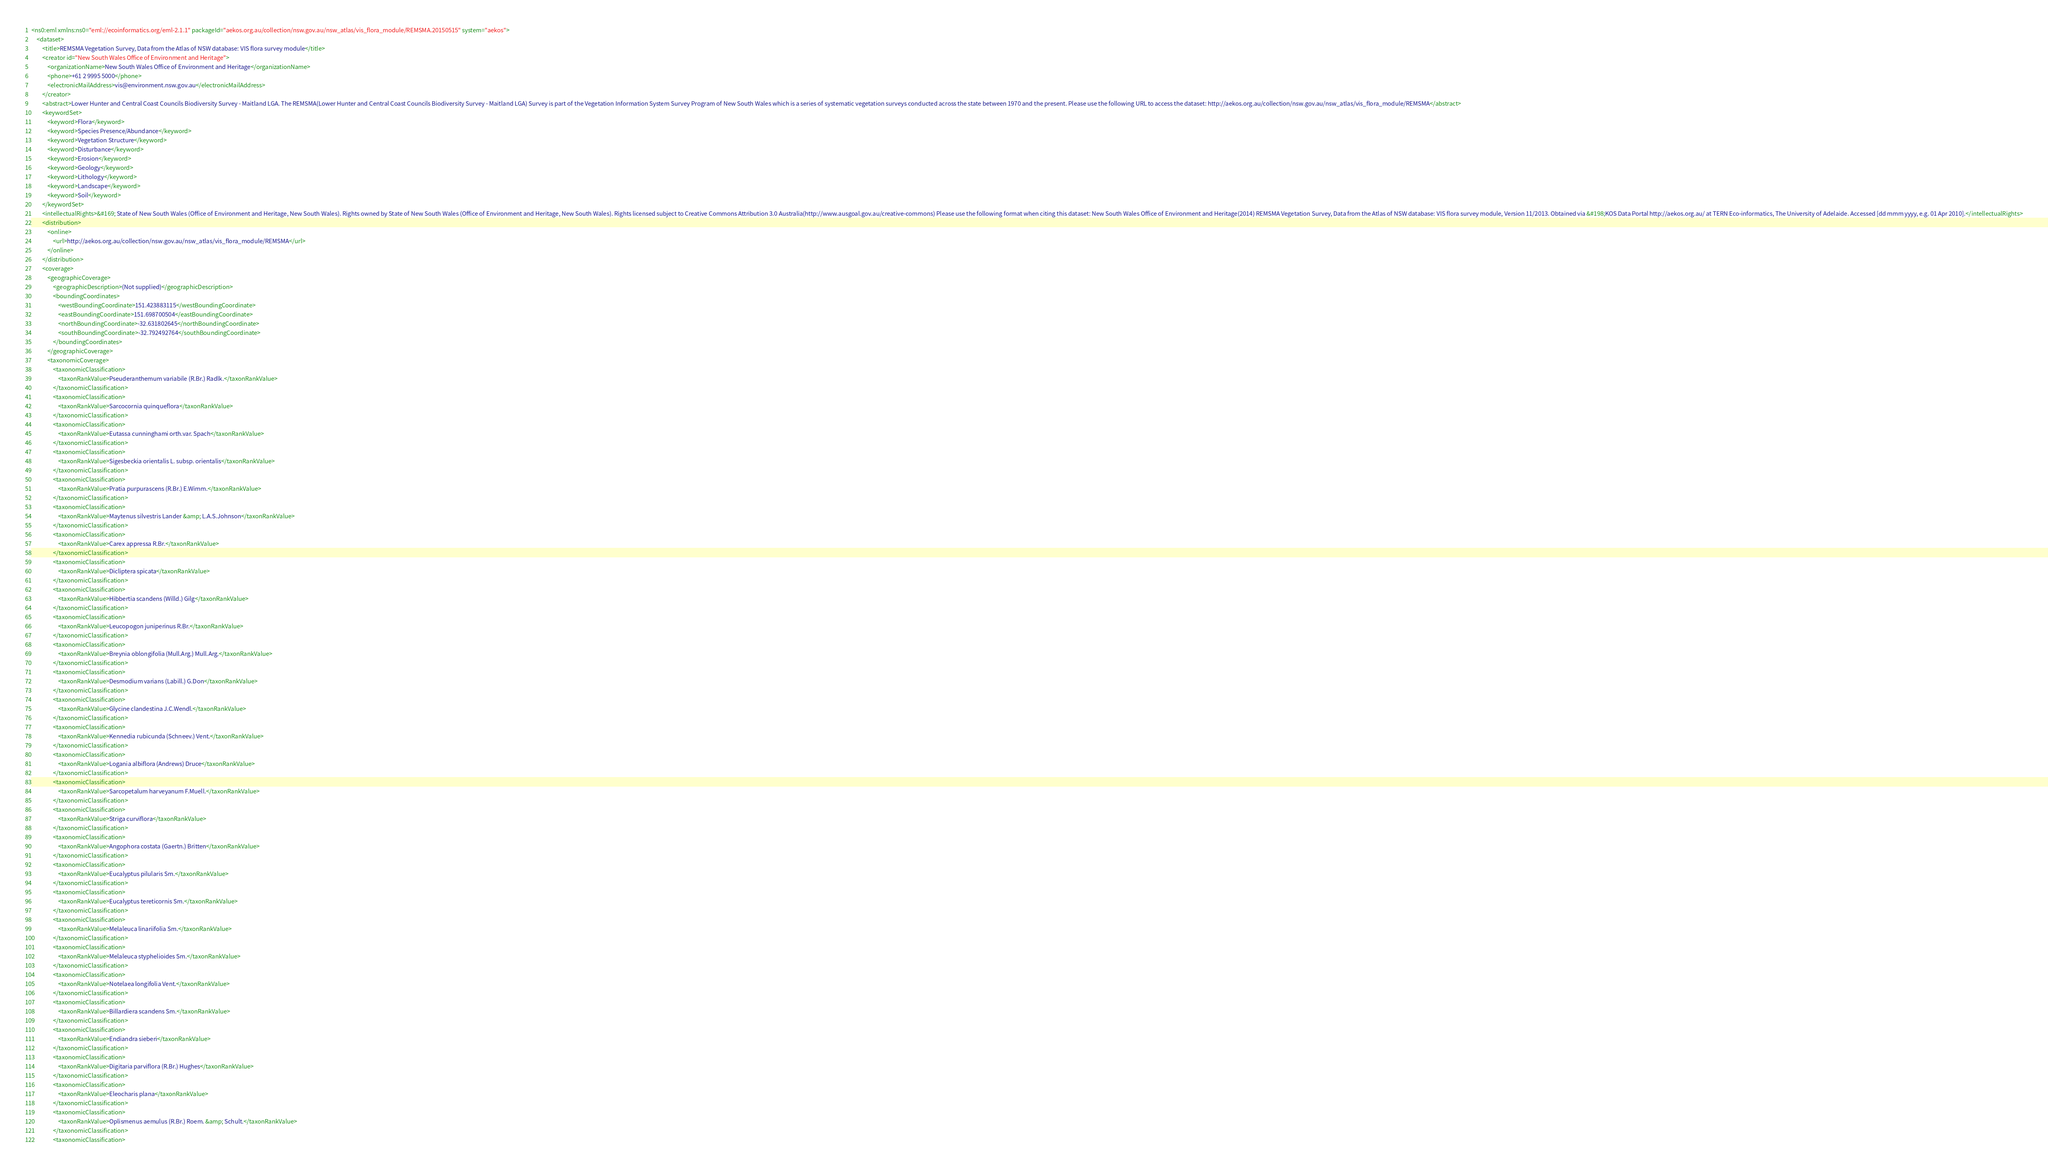<code> <loc_0><loc_0><loc_500><loc_500><_XML_><ns0:eml xmlns:ns0="eml://ecoinformatics.org/eml-2.1.1" packageId="aekos.org.au/collection/nsw.gov.au/nsw_atlas/vis_flora_module/REMSMA.20150515" system="aekos">
    <dataset>
        <title>REMSMA Vegetation Survey, Data from the Atlas of NSW database: VIS flora survey module</title>
        <creator id="New South Wales Office of Environment and Heritage">
            <organizationName>New South Wales Office of Environment and Heritage</organizationName>
            <phone>+61 2 9995 5000</phone>
            <electronicMailAddress>vis@environment.nsw.gov.au</electronicMailAddress>
        </creator>
        <abstract>Lower Hunter and Central Coast Councils Biodiversity Survey - Maitland LGA. The REMSMA(Lower Hunter and Central Coast Councils Biodiversity Survey - Maitland LGA) Survey is part of the Vegetation Information System Survey Program of New South Wales which is a series of systematic vegetation surveys conducted across the state between 1970 and the present. Please use the following URL to access the dataset: http://aekos.org.au/collection/nsw.gov.au/nsw_atlas/vis_flora_module/REMSMA</abstract>
        <keywordSet>
            <keyword>Flora</keyword>
            <keyword>Species Presence/Abundance</keyword>
            <keyword>Vegetation Structure</keyword>
            <keyword>Disturbance</keyword>
            <keyword>Erosion</keyword>
            <keyword>Geology</keyword>
            <keyword>Lithology</keyword>
            <keyword>Landscape</keyword>
            <keyword>Soil</keyword>
        </keywordSet>
        <intellectualRights>&#169; State of New South Wales (Office of Environment and Heritage, New South Wales). Rights owned by State of New South Wales (Office of Environment and Heritage, New South Wales). Rights licensed subject to Creative Commons Attribution 3.0 Australia(http://www.ausgoal.gov.au/creative-commons) Please use the following format when citing this dataset: New South Wales Office of Environment and Heritage(2014) REMSMA Vegetation Survey, Data from the Atlas of NSW database: VIS flora survey module, Version 11/2013. Obtained via &#198;KOS Data Portal http://aekos.org.au/ at TERN Eco-informatics, The University of Adelaide. Accessed [dd mmm yyyy, e.g. 01 Apr 2010].</intellectualRights>
        <distribution>
            <online>
                <url>http://aekos.org.au/collection/nsw.gov.au/nsw_atlas/vis_flora_module/REMSMA</url>
            </online>
        </distribution>
        <coverage>
            <geographicCoverage>
                <geographicDescription>(Not supplied)</geographicDescription>
                <boundingCoordinates>
                    <westBoundingCoordinate>151.423883115</westBoundingCoordinate>
                    <eastBoundingCoordinate>151.698700504</eastBoundingCoordinate>
                    <northBoundingCoordinate>-32.631802645</northBoundingCoordinate>
                    <southBoundingCoordinate>-32.792492764</southBoundingCoordinate>
                </boundingCoordinates>
            </geographicCoverage>
            <taxonomicCoverage>
                <taxonomicClassification>
                    <taxonRankValue>Pseuderanthemum variabile (R.Br.) Radlk.</taxonRankValue>
                </taxonomicClassification>
                <taxonomicClassification>
                    <taxonRankValue>Sarcocornia quinqueflora</taxonRankValue>
                </taxonomicClassification>
                <taxonomicClassification>
                    <taxonRankValue>Eutassa cunninghami orth.var. Spach</taxonRankValue>
                </taxonomicClassification>
                <taxonomicClassification>
                    <taxonRankValue>Sigesbeckia orientalis L. subsp. orientalis</taxonRankValue>
                </taxonomicClassification>
                <taxonomicClassification>
                    <taxonRankValue>Pratia purpurascens (R.Br.) E.Wimm.</taxonRankValue>
                </taxonomicClassification>
                <taxonomicClassification>
                    <taxonRankValue>Maytenus silvestris Lander &amp; L.A.S.Johnson</taxonRankValue>
                </taxonomicClassification>
                <taxonomicClassification>
                    <taxonRankValue>Carex appressa R.Br.</taxonRankValue>
                </taxonomicClassification>
                <taxonomicClassification>
                    <taxonRankValue>Dicliptera spicata</taxonRankValue>
                </taxonomicClassification>
                <taxonomicClassification>
                    <taxonRankValue>Hibbertia scandens (Willd.) Gilg</taxonRankValue>
                </taxonomicClassification>
                <taxonomicClassification>
                    <taxonRankValue>Leucopogon juniperinus R.Br.</taxonRankValue>
                </taxonomicClassification>
                <taxonomicClassification>
                    <taxonRankValue>Breynia oblongifolia (Mull.Arg.) Mull.Arg.</taxonRankValue>
                </taxonomicClassification>
                <taxonomicClassification>
                    <taxonRankValue>Desmodium varians (Labill.) G.Don</taxonRankValue>
                </taxonomicClassification>
                <taxonomicClassification>
                    <taxonRankValue>Glycine clandestina J.C.Wendl.</taxonRankValue>
                </taxonomicClassification>
                <taxonomicClassification>
                    <taxonRankValue>Kennedia rubicunda (Schneev.) Vent.</taxonRankValue>
                </taxonomicClassification>
                <taxonomicClassification>
                    <taxonRankValue>Logania albiflora (Andrews) Druce</taxonRankValue>
                </taxonomicClassification>
                <taxonomicClassification>
                    <taxonRankValue>Sarcopetalum harveyanum F.Muell.</taxonRankValue>
                </taxonomicClassification>
                <taxonomicClassification>
                    <taxonRankValue>Striga curviflora</taxonRankValue>
                </taxonomicClassification>
                <taxonomicClassification>
                    <taxonRankValue>Angophora costata (Gaertn.) Britten</taxonRankValue>
                </taxonomicClassification>
                <taxonomicClassification>
                    <taxonRankValue>Eucalyptus pilularis Sm.</taxonRankValue>
                </taxonomicClassification>
                <taxonomicClassification>
                    <taxonRankValue>Eucalyptus tereticornis Sm.</taxonRankValue>
                </taxonomicClassification>
                <taxonomicClassification>
                    <taxonRankValue>Melaleuca linariifolia Sm.</taxonRankValue>
                </taxonomicClassification>
                <taxonomicClassification>
                    <taxonRankValue>Melaleuca styphelioides Sm.</taxonRankValue>
                </taxonomicClassification>
                <taxonomicClassification>
                    <taxonRankValue>Notelaea longifolia Vent.</taxonRankValue>
                </taxonomicClassification>
                <taxonomicClassification>
                    <taxonRankValue>Billardiera scandens Sm.</taxonRankValue>
                </taxonomicClassification>
                <taxonomicClassification>
                    <taxonRankValue>Endiandra sieberi</taxonRankValue>
                </taxonomicClassification>
                <taxonomicClassification>
                    <taxonRankValue>Digitaria parviflora (R.Br.) Hughes</taxonRankValue>
                </taxonomicClassification>
                <taxonomicClassification>
                    <taxonRankValue>Eleocharis plana</taxonRankValue>
                </taxonomicClassification>
                <taxonomicClassification>
                    <taxonRankValue>Oplismenus aemulus (R.Br.) Roem. &amp; Schult.</taxonRankValue>
                </taxonomicClassification>
                <taxonomicClassification></code> 